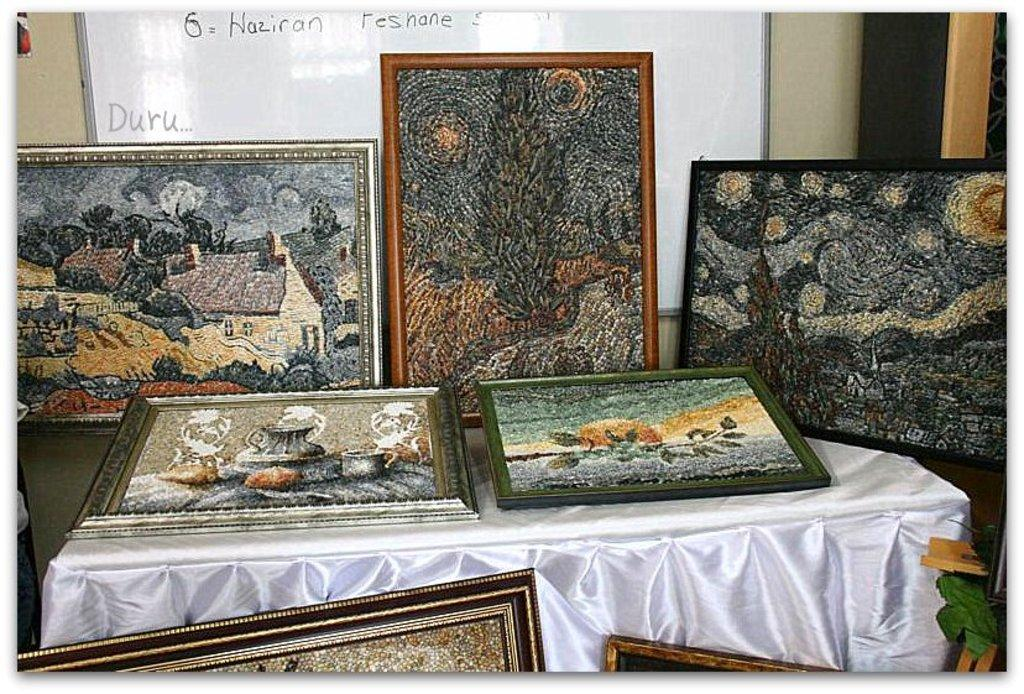What objects are arranged on the table in the image? There are photo frames arranged on a table in the image. Can you describe anything visible on the wall in the background? There is a board attached to the wall in the background. How many servants are visible in the image? There are no servants present in the image. What type of flight is taking off in the background of the image? There is no flight present in the image; it only shows photo frames on a table and a board on the wall in the background. 